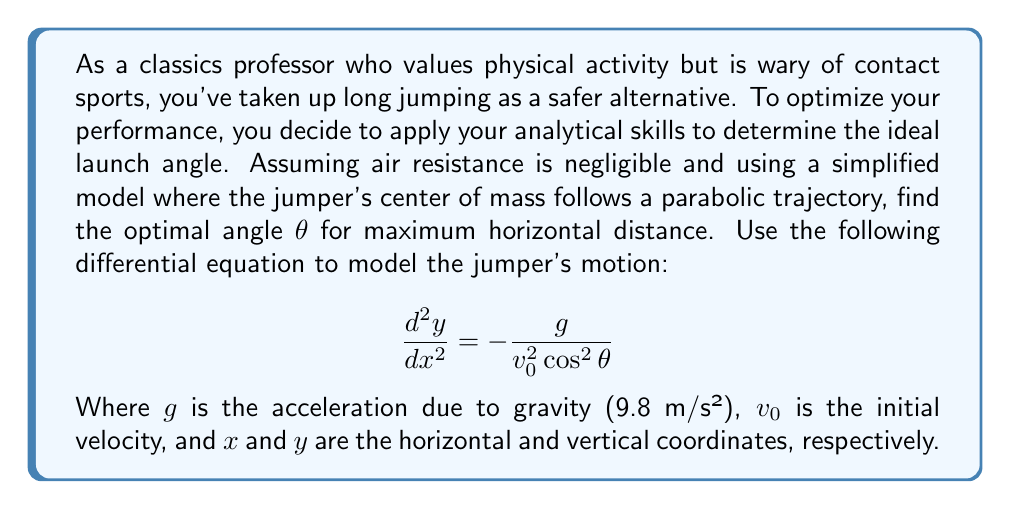Teach me how to tackle this problem. To solve this problem, we'll follow these steps:

1) First, we need to solve the differential equation. The general solution is:

   $$y = -\frac{gx^2}{2v_0^2 \cos^2 θ} + (tan θ)x + C$$

2) The initial conditions are $y(0) = 0$ and $y(R) = 0$, where $R$ is the horizontal distance of the jump. Applying these:

   At $x = 0$: $0 = C$, so $C = 0$
   At $x = R$: $0 = -\frac{gR^2}{2v_0^2 \cos^2 θ} + (tan θ)R$

3) From the second condition:

   $$\frac{gR}{2v_0^2 \cos^2 θ} = tan θ$$

4) We can express $R$ in terms of θ:

   $$R = \frac{2v_0^2}{g} \sin θ \cos θ = \frac{v_0^2}{g} \sin 2θ$$

5) To find the maximum $R$, we differentiate with respect to θ and set it to zero:

   $$\frac{dR}{dθ} = \frac{v_0^2}{g} 2\cos 2θ = 0$$

6) Solving this:

   $\cos 2θ = 0$
   $2θ = 90°$
   $θ = 45°$

7) We can confirm this is a maximum by checking the second derivative is negative at this point.

Therefore, the optimal angle for maximum horizontal distance in a long jump is 45°.
Answer: The optimal angle for a long jump, assuming no air resistance, is 45°. 